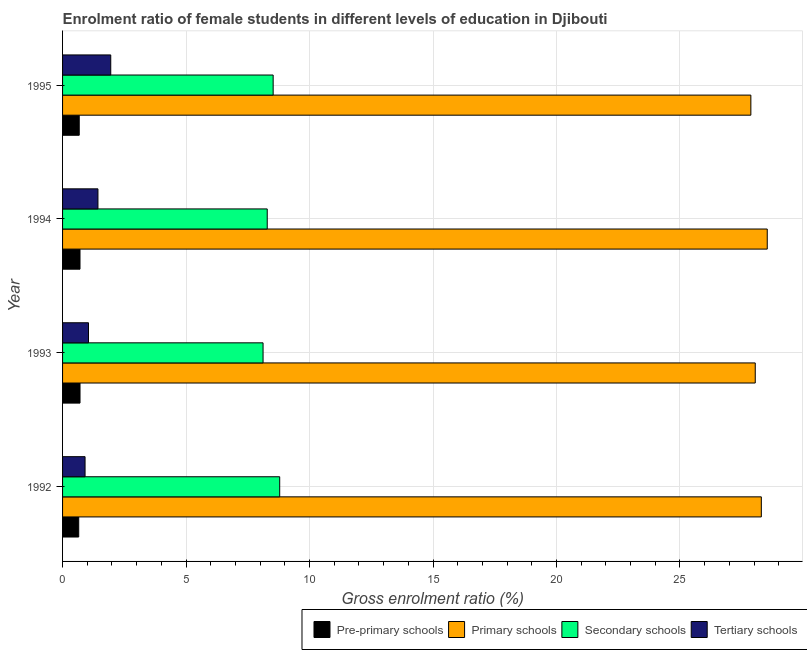How many different coloured bars are there?
Make the answer very short. 4. How many groups of bars are there?
Your response must be concise. 4. Are the number of bars per tick equal to the number of legend labels?
Ensure brevity in your answer.  Yes. Are the number of bars on each tick of the Y-axis equal?
Provide a short and direct response. Yes. How many bars are there on the 3rd tick from the top?
Offer a terse response. 4. How many bars are there on the 3rd tick from the bottom?
Provide a short and direct response. 4. What is the label of the 2nd group of bars from the top?
Your answer should be very brief. 1994. In how many cases, is the number of bars for a given year not equal to the number of legend labels?
Your response must be concise. 0. What is the gross enrolment ratio(male) in pre-primary schools in 1992?
Provide a short and direct response. 0.65. Across all years, what is the maximum gross enrolment ratio(male) in secondary schools?
Your answer should be compact. 8.79. Across all years, what is the minimum gross enrolment ratio(male) in primary schools?
Offer a very short reply. 27.87. In which year was the gross enrolment ratio(male) in tertiary schools maximum?
Offer a very short reply. 1995. In which year was the gross enrolment ratio(male) in pre-primary schools minimum?
Give a very brief answer. 1992. What is the total gross enrolment ratio(male) in tertiary schools in the graph?
Your answer should be very brief. 5.35. What is the difference between the gross enrolment ratio(male) in tertiary schools in 1992 and that in 1995?
Keep it short and to the point. -1.04. What is the difference between the gross enrolment ratio(male) in secondary schools in 1994 and the gross enrolment ratio(male) in pre-primary schools in 1993?
Keep it short and to the point. 7.58. What is the average gross enrolment ratio(male) in secondary schools per year?
Make the answer very short. 8.43. In the year 1994, what is the difference between the gross enrolment ratio(male) in pre-primary schools and gross enrolment ratio(male) in primary schools?
Give a very brief answer. -27.83. What is the ratio of the gross enrolment ratio(male) in pre-primary schools in 1992 to that in 1993?
Provide a short and direct response. 0.93. What is the difference between the highest and the second highest gross enrolment ratio(male) in primary schools?
Offer a terse response. 0.24. Is it the case that in every year, the sum of the gross enrolment ratio(male) in tertiary schools and gross enrolment ratio(male) in secondary schools is greater than the sum of gross enrolment ratio(male) in primary schools and gross enrolment ratio(male) in pre-primary schools?
Your answer should be compact. No. What does the 3rd bar from the top in 1992 represents?
Ensure brevity in your answer.  Primary schools. What does the 4th bar from the bottom in 1994 represents?
Your answer should be very brief. Tertiary schools. Are all the bars in the graph horizontal?
Your answer should be very brief. Yes. How many years are there in the graph?
Your answer should be very brief. 4. What is the difference between two consecutive major ticks on the X-axis?
Your answer should be very brief. 5. Are the values on the major ticks of X-axis written in scientific E-notation?
Offer a terse response. No. Does the graph contain any zero values?
Make the answer very short. No. How many legend labels are there?
Your answer should be very brief. 4. What is the title of the graph?
Keep it short and to the point. Enrolment ratio of female students in different levels of education in Djibouti. What is the label or title of the Y-axis?
Make the answer very short. Year. What is the Gross enrolment ratio (%) of Pre-primary schools in 1992?
Offer a terse response. 0.65. What is the Gross enrolment ratio (%) of Primary schools in 1992?
Make the answer very short. 28.3. What is the Gross enrolment ratio (%) in Secondary schools in 1992?
Make the answer very short. 8.79. What is the Gross enrolment ratio (%) of Tertiary schools in 1992?
Provide a short and direct response. 0.91. What is the Gross enrolment ratio (%) of Pre-primary schools in 1993?
Offer a terse response. 0.71. What is the Gross enrolment ratio (%) in Primary schools in 1993?
Offer a very short reply. 28.05. What is the Gross enrolment ratio (%) of Secondary schools in 1993?
Make the answer very short. 8.12. What is the Gross enrolment ratio (%) of Tertiary schools in 1993?
Ensure brevity in your answer.  1.05. What is the Gross enrolment ratio (%) in Pre-primary schools in 1994?
Ensure brevity in your answer.  0.71. What is the Gross enrolment ratio (%) of Primary schools in 1994?
Your answer should be very brief. 28.54. What is the Gross enrolment ratio (%) in Secondary schools in 1994?
Provide a short and direct response. 8.29. What is the Gross enrolment ratio (%) in Tertiary schools in 1994?
Offer a very short reply. 1.43. What is the Gross enrolment ratio (%) in Pre-primary schools in 1995?
Provide a short and direct response. 0.67. What is the Gross enrolment ratio (%) of Primary schools in 1995?
Offer a terse response. 27.87. What is the Gross enrolment ratio (%) of Secondary schools in 1995?
Offer a very short reply. 8.53. What is the Gross enrolment ratio (%) in Tertiary schools in 1995?
Your answer should be compact. 1.95. Across all years, what is the maximum Gross enrolment ratio (%) of Pre-primary schools?
Give a very brief answer. 0.71. Across all years, what is the maximum Gross enrolment ratio (%) of Primary schools?
Offer a very short reply. 28.54. Across all years, what is the maximum Gross enrolment ratio (%) in Secondary schools?
Make the answer very short. 8.79. Across all years, what is the maximum Gross enrolment ratio (%) of Tertiary schools?
Your answer should be very brief. 1.95. Across all years, what is the minimum Gross enrolment ratio (%) in Pre-primary schools?
Offer a terse response. 0.65. Across all years, what is the minimum Gross enrolment ratio (%) of Primary schools?
Ensure brevity in your answer.  27.87. Across all years, what is the minimum Gross enrolment ratio (%) of Secondary schools?
Your answer should be compact. 8.12. Across all years, what is the minimum Gross enrolment ratio (%) of Tertiary schools?
Provide a succinct answer. 0.91. What is the total Gross enrolment ratio (%) in Pre-primary schools in the graph?
Your answer should be compact. 2.74. What is the total Gross enrolment ratio (%) in Primary schools in the graph?
Keep it short and to the point. 112.75. What is the total Gross enrolment ratio (%) of Secondary schools in the graph?
Make the answer very short. 33.73. What is the total Gross enrolment ratio (%) in Tertiary schools in the graph?
Give a very brief answer. 5.35. What is the difference between the Gross enrolment ratio (%) in Pre-primary schools in 1992 and that in 1993?
Ensure brevity in your answer.  -0.05. What is the difference between the Gross enrolment ratio (%) in Primary schools in 1992 and that in 1993?
Offer a very short reply. 0.25. What is the difference between the Gross enrolment ratio (%) in Secondary schools in 1992 and that in 1993?
Offer a very short reply. 0.67. What is the difference between the Gross enrolment ratio (%) of Tertiary schools in 1992 and that in 1993?
Your response must be concise. -0.14. What is the difference between the Gross enrolment ratio (%) in Pre-primary schools in 1992 and that in 1994?
Provide a short and direct response. -0.05. What is the difference between the Gross enrolment ratio (%) of Primary schools in 1992 and that in 1994?
Make the answer very short. -0.24. What is the difference between the Gross enrolment ratio (%) in Secondary schools in 1992 and that in 1994?
Offer a terse response. 0.5. What is the difference between the Gross enrolment ratio (%) in Tertiary schools in 1992 and that in 1994?
Your answer should be compact. -0.52. What is the difference between the Gross enrolment ratio (%) in Pre-primary schools in 1992 and that in 1995?
Your answer should be compact. -0.02. What is the difference between the Gross enrolment ratio (%) of Primary schools in 1992 and that in 1995?
Provide a succinct answer. 0.42. What is the difference between the Gross enrolment ratio (%) in Secondary schools in 1992 and that in 1995?
Provide a succinct answer. 0.26. What is the difference between the Gross enrolment ratio (%) of Tertiary schools in 1992 and that in 1995?
Give a very brief answer. -1.04. What is the difference between the Gross enrolment ratio (%) in Pre-primary schools in 1993 and that in 1994?
Provide a short and direct response. 0. What is the difference between the Gross enrolment ratio (%) of Primary schools in 1993 and that in 1994?
Provide a succinct answer. -0.49. What is the difference between the Gross enrolment ratio (%) in Secondary schools in 1993 and that in 1994?
Give a very brief answer. -0.17. What is the difference between the Gross enrolment ratio (%) in Tertiary schools in 1993 and that in 1994?
Your response must be concise. -0.38. What is the difference between the Gross enrolment ratio (%) of Pre-primary schools in 1993 and that in 1995?
Make the answer very short. 0.03. What is the difference between the Gross enrolment ratio (%) in Primary schools in 1993 and that in 1995?
Keep it short and to the point. 0.18. What is the difference between the Gross enrolment ratio (%) of Secondary schools in 1993 and that in 1995?
Provide a short and direct response. -0.41. What is the difference between the Gross enrolment ratio (%) in Tertiary schools in 1993 and that in 1995?
Make the answer very short. -0.9. What is the difference between the Gross enrolment ratio (%) in Pre-primary schools in 1994 and that in 1995?
Keep it short and to the point. 0.03. What is the difference between the Gross enrolment ratio (%) in Primary schools in 1994 and that in 1995?
Offer a very short reply. 0.66. What is the difference between the Gross enrolment ratio (%) in Secondary schools in 1994 and that in 1995?
Offer a very short reply. -0.24. What is the difference between the Gross enrolment ratio (%) in Tertiary schools in 1994 and that in 1995?
Your answer should be very brief. -0.52. What is the difference between the Gross enrolment ratio (%) of Pre-primary schools in 1992 and the Gross enrolment ratio (%) of Primary schools in 1993?
Provide a succinct answer. -27.39. What is the difference between the Gross enrolment ratio (%) in Pre-primary schools in 1992 and the Gross enrolment ratio (%) in Secondary schools in 1993?
Keep it short and to the point. -7.46. What is the difference between the Gross enrolment ratio (%) of Pre-primary schools in 1992 and the Gross enrolment ratio (%) of Tertiary schools in 1993?
Your answer should be very brief. -0.4. What is the difference between the Gross enrolment ratio (%) of Primary schools in 1992 and the Gross enrolment ratio (%) of Secondary schools in 1993?
Your answer should be compact. 20.18. What is the difference between the Gross enrolment ratio (%) of Primary schools in 1992 and the Gross enrolment ratio (%) of Tertiary schools in 1993?
Ensure brevity in your answer.  27.25. What is the difference between the Gross enrolment ratio (%) in Secondary schools in 1992 and the Gross enrolment ratio (%) in Tertiary schools in 1993?
Ensure brevity in your answer.  7.74. What is the difference between the Gross enrolment ratio (%) of Pre-primary schools in 1992 and the Gross enrolment ratio (%) of Primary schools in 1994?
Your answer should be compact. -27.88. What is the difference between the Gross enrolment ratio (%) of Pre-primary schools in 1992 and the Gross enrolment ratio (%) of Secondary schools in 1994?
Give a very brief answer. -7.63. What is the difference between the Gross enrolment ratio (%) in Pre-primary schools in 1992 and the Gross enrolment ratio (%) in Tertiary schools in 1994?
Give a very brief answer. -0.78. What is the difference between the Gross enrolment ratio (%) of Primary schools in 1992 and the Gross enrolment ratio (%) of Secondary schools in 1994?
Ensure brevity in your answer.  20.01. What is the difference between the Gross enrolment ratio (%) of Primary schools in 1992 and the Gross enrolment ratio (%) of Tertiary schools in 1994?
Keep it short and to the point. 26.86. What is the difference between the Gross enrolment ratio (%) in Secondary schools in 1992 and the Gross enrolment ratio (%) in Tertiary schools in 1994?
Provide a succinct answer. 7.36. What is the difference between the Gross enrolment ratio (%) in Pre-primary schools in 1992 and the Gross enrolment ratio (%) in Primary schools in 1995?
Ensure brevity in your answer.  -27.22. What is the difference between the Gross enrolment ratio (%) in Pre-primary schools in 1992 and the Gross enrolment ratio (%) in Secondary schools in 1995?
Your answer should be very brief. -7.87. What is the difference between the Gross enrolment ratio (%) of Pre-primary schools in 1992 and the Gross enrolment ratio (%) of Tertiary schools in 1995?
Make the answer very short. -1.3. What is the difference between the Gross enrolment ratio (%) of Primary schools in 1992 and the Gross enrolment ratio (%) of Secondary schools in 1995?
Offer a very short reply. 19.77. What is the difference between the Gross enrolment ratio (%) of Primary schools in 1992 and the Gross enrolment ratio (%) of Tertiary schools in 1995?
Your answer should be compact. 26.34. What is the difference between the Gross enrolment ratio (%) of Secondary schools in 1992 and the Gross enrolment ratio (%) of Tertiary schools in 1995?
Provide a short and direct response. 6.84. What is the difference between the Gross enrolment ratio (%) of Pre-primary schools in 1993 and the Gross enrolment ratio (%) of Primary schools in 1994?
Your answer should be very brief. -27.83. What is the difference between the Gross enrolment ratio (%) of Pre-primary schools in 1993 and the Gross enrolment ratio (%) of Secondary schools in 1994?
Make the answer very short. -7.58. What is the difference between the Gross enrolment ratio (%) of Pre-primary schools in 1993 and the Gross enrolment ratio (%) of Tertiary schools in 1994?
Provide a succinct answer. -0.73. What is the difference between the Gross enrolment ratio (%) of Primary schools in 1993 and the Gross enrolment ratio (%) of Secondary schools in 1994?
Keep it short and to the point. 19.76. What is the difference between the Gross enrolment ratio (%) in Primary schools in 1993 and the Gross enrolment ratio (%) in Tertiary schools in 1994?
Ensure brevity in your answer.  26.62. What is the difference between the Gross enrolment ratio (%) of Secondary schools in 1993 and the Gross enrolment ratio (%) of Tertiary schools in 1994?
Your answer should be compact. 6.69. What is the difference between the Gross enrolment ratio (%) in Pre-primary schools in 1993 and the Gross enrolment ratio (%) in Primary schools in 1995?
Give a very brief answer. -27.16. What is the difference between the Gross enrolment ratio (%) of Pre-primary schools in 1993 and the Gross enrolment ratio (%) of Secondary schools in 1995?
Make the answer very short. -7.82. What is the difference between the Gross enrolment ratio (%) of Pre-primary schools in 1993 and the Gross enrolment ratio (%) of Tertiary schools in 1995?
Keep it short and to the point. -1.24. What is the difference between the Gross enrolment ratio (%) in Primary schools in 1993 and the Gross enrolment ratio (%) in Secondary schools in 1995?
Your answer should be compact. 19.52. What is the difference between the Gross enrolment ratio (%) of Primary schools in 1993 and the Gross enrolment ratio (%) of Tertiary schools in 1995?
Offer a very short reply. 26.1. What is the difference between the Gross enrolment ratio (%) of Secondary schools in 1993 and the Gross enrolment ratio (%) of Tertiary schools in 1995?
Provide a succinct answer. 6.17. What is the difference between the Gross enrolment ratio (%) in Pre-primary schools in 1994 and the Gross enrolment ratio (%) in Primary schools in 1995?
Provide a short and direct response. -27.16. What is the difference between the Gross enrolment ratio (%) of Pre-primary schools in 1994 and the Gross enrolment ratio (%) of Secondary schools in 1995?
Your answer should be compact. -7.82. What is the difference between the Gross enrolment ratio (%) of Pre-primary schools in 1994 and the Gross enrolment ratio (%) of Tertiary schools in 1995?
Your response must be concise. -1.25. What is the difference between the Gross enrolment ratio (%) in Primary schools in 1994 and the Gross enrolment ratio (%) in Secondary schools in 1995?
Make the answer very short. 20.01. What is the difference between the Gross enrolment ratio (%) in Primary schools in 1994 and the Gross enrolment ratio (%) in Tertiary schools in 1995?
Give a very brief answer. 26.58. What is the difference between the Gross enrolment ratio (%) in Secondary schools in 1994 and the Gross enrolment ratio (%) in Tertiary schools in 1995?
Your answer should be compact. 6.34. What is the average Gross enrolment ratio (%) of Pre-primary schools per year?
Your answer should be very brief. 0.69. What is the average Gross enrolment ratio (%) in Primary schools per year?
Provide a succinct answer. 28.19. What is the average Gross enrolment ratio (%) in Secondary schools per year?
Make the answer very short. 8.43. What is the average Gross enrolment ratio (%) of Tertiary schools per year?
Provide a short and direct response. 1.34. In the year 1992, what is the difference between the Gross enrolment ratio (%) in Pre-primary schools and Gross enrolment ratio (%) in Primary schools?
Give a very brief answer. -27.64. In the year 1992, what is the difference between the Gross enrolment ratio (%) in Pre-primary schools and Gross enrolment ratio (%) in Secondary schools?
Your response must be concise. -8.14. In the year 1992, what is the difference between the Gross enrolment ratio (%) of Pre-primary schools and Gross enrolment ratio (%) of Tertiary schools?
Offer a very short reply. -0.26. In the year 1992, what is the difference between the Gross enrolment ratio (%) of Primary schools and Gross enrolment ratio (%) of Secondary schools?
Keep it short and to the point. 19.5. In the year 1992, what is the difference between the Gross enrolment ratio (%) in Primary schools and Gross enrolment ratio (%) in Tertiary schools?
Give a very brief answer. 27.38. In the year 1992, what is the difference between the Gross enrolment ratio (%) of Secondary schools and Gross enrolment ratio (%) of Tertiary schools?
Provide a succinct answer. 7.88. In the year 1993, what is the difference between the Gross enrolment ratio (%) in Pre-primary schools and Gross enrolment ratio (%) in Primary schools?
Offer a very short reply. -27.34. In the year 1993, what is the difference between the Gross enrolment ratio (%) in Pre-primary schools and Gross enrolment ratio (%) in Secondary schools?
Offer a terse response. -7.41. In the year 1993, what is the difference between the Gross enrolment ratio (%) in Pre-primary schools and Gross enrolment ratio (%) in Tertiary schools?
Ensure brevity in your answer.  -0.34. In the year 1993, what is the difference between the Gross enrolment ratio (%) in Primary schools and Gross enrolment ratio (%) in Secondary schools?
Offer a terse response. 19.93. In the year 1993, what is the difference between the Gross enrolment ratio (%) of Primary schools and Gross enrolment ratio (%) of Tertiary schools?
Your response must be concise. 27. In the year 1993, what is the difference between the Gross enrolment ratio (%) in Secondary schools and Gross enrolment ratio (%) in Tertiary schools?
Keep it short and to the point. 7.07. In the year 1994, what is the difference between the Gross enrolment ratio (%) in Pre-primary schools and Gross enrolment ratio (%) in Primary schools?
Provide a succinct answer. -27.83. In the year 1994, what is the difference between the Gross enrolment ratio (%) in Pre-primary schools and Gross enrolment ratio (%) in Secondary schools?
Give a very brief answer. -7.58. In the year 1994, what is the difference between the Gross enrolment ratio (%) of Pre-primary schools and Gross enrolment ratio (%) of Tertiary schools?
Offer a very short reply. -0.73. In the year 1994, what is the difference between the Gross enrolment ratio (%) in Primary schools and Gross enrolment ratio (%) in Secondary schools?
Give a very brief answer. 20.25. In the year 1994, what is the difference between the Gross enrolment ratio (%) of Primary schools and Gross enrolment ratio (%) of Tertiary schools?
Give a very brief answer. 27.1. In the year 1994, what is the difference between the Gross enrolment ratio (%) in Secondary schools and Gross enrolment ratio (%) in Tertiary schools?
Make the answer very short. 6.86. In the year 1995, what is the difference between the Gross enrolment ratio (%) in Pre-primary schools and Gross enrolment ratio (%) in Primary schools?
Make the answer very short. -27.2. In the year 1995, what is the difference between the Gross enrolment ratio (%) of Pre-primary schools and Gross enrolment ratio (%) of Secondary schools?
Ensure brevity in your answer.  -7.85. In the year 1995, what is the difference between the Gross enrolment ratio (%) of Pre-primary schools and Gross enrolment ratio (%) of Tertiary schools?
Ensure brevity in your answer.  -1.28. In the year 1995, what is the difference between the Gross enrolment ratio (%) in Primary schools and Gross enrolment ratio (%) in Secondary schools?
Your answer should be compact. 19.34. In the year 1995, what is the difference between the Gross enrolment ratio (%) in Primary schools and Gross enrolment ratio (%) in Tertiary schools?
Your response must be concise. 25.92. In the year 1995, what is the difference between the Gross enrolment ratio (%) of Secondary schools and Gross enrolment ratio (%) of Tertiary schools?
Your response must be concise. 6.58. What is the ratio of the Gross enrolment ratio (%) of Pre-primary schools in 1992 to that in 1993?
Offer a very short reply. 0.93. What is the ratio of the Gross enrolment ratio (%) in Primary schools in 1992 to that in 1993?
Your answer should be very brief. 1.01. What is the ratio of the Gross enrolment ratio (%) of Secondary schools in 1992 to that in 1993?
Your answer should be very brief. 1.08. What is the ratio of the Gross enrolment ratio (%) of Tertiary schools in 1992 to that in 1993?
Your answer should be compact. 0.87. What is the ratio of the Gross enrolment ratio (%) of Pre-primary schools in 1992 to that in 1994?
Make the answer very short. 0.93. What is the ratio of the Gross enrolment ratio (%) of Secondary schools in 1992 to that in 1994?
Offer a terse response. 1.06. What is the ratio of the Gross enrolment ratio (%) in Tertiary schools in 1992 to that in 1994?
Give a very brief answer. 0.64. What is the ratio of the Gross enrolment ratio (%) in Pre-primary schools in 1992 to that in 1995?
Give a very brief answer. 0.97. What is the ratio of the Gross enrolment ratio (%) of Primary schools in 1992 to that in 1995?
Your answer should be very brief. 1.02. What is the ratio of the Gross enrolment ratio (%) of Secondary schools in 1992 to that in 1995?
Offer a terse response. 1.03. What is the ratio of the Gross enrolment ratio (%) of Tertiary schools in 1992 to that in 1995?
Provide a short and direct response. 0.47. What is the ratio of the Gross enrolment ratio (%) in Pre-primary schools in 1993 to that in 1994?
Your response must be concise. 1. What is the ratio of the Gross enrolment ratio (%) in Primary schools in 1993 to that in 1994?
Keep it short and to the point. 0.98. What is the ratio of the Gross enrolment ratio (%) of Secondary schools in 1993 to that in 1994?
Provide a succinct answer. 0.98. What is the ratio of the Gross enrolment ratio (%) in Tertiary schools in 1993 to that in 1994?
Give a very brief answer. 0.73. What is the ratio of the Gross enrolment ratio (%) of Pre-primary schools in 1993 to that in 1995?
Offer a very short reply. 1.05. What is the ratio of the Gross enrolment ratio (%) of Primary schools in 1993 to that in 1995?
Your response must be concise. 1.01. What is the ratio of the Gross enrolment ratio (%) of Tertiary schools in 1993 to that in 1995?
Keep it short and to the point. 0.54. What is the ratio of the Gross enrolment ratio (%) in Pre-primary schools in 1994 to that in 1995?
Make the answer very short. 1.05. What is the ratio of the Gross enrolment ratio (%) in Primary schools in 1994 to that in 1995?
Give a very brief answer. 1.02. What is the ratio of the Gross enrolment ratio (%) of Secondary schools in 1994 to that in 1995?
Make the answer very short. 0.97. What is the ratio of the Gross enrolment ratio (%) of Tertiary schools in 1994 to that in 1995?
Make the answer very short. 0.73. What is the difference between the highest and the second highest Gross enrolment ratio (%) of Primary schools?
Provide a short and direct response. 0.24. What is the difference between the highest and the second highest Gross enrolment ratio (%) of Secondary schools?
Offer a very short reply. 0.26. What is the difference between the highest and the second highest Gross enrolment ratio (%) of Tertiary schools?
Provide a short and direct response. 0.52. What is the difference between the highest and the lowest Gross enrolment ratio (%) of Pre-primary schools?
Your response must be concise. 0.05. What is the difference between the highest and the lowest Gross enrolment ratio (%) of Primary schools?
Your answer should be very brief. 0.66. What is the difference between the highest and the lowest Gross enrolment ratio (%) in Secondary schools?
Your answer should be very brief. 0.67. What is the difference between the highest and the lowest Gross enrolment ratio (%) of Tertiary schools?
Ensure brevity in your answer.  1.04. 